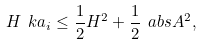Convert formula to latex. <formula><loc_0><loc_0><loc_500><loc_500>H \ k a _ { i } \leq \frac { 1 } { 2 } H ^ { 2 } + \frac { 1 } { 2 } \ a b s A ^ { 2 } ,</formula> 